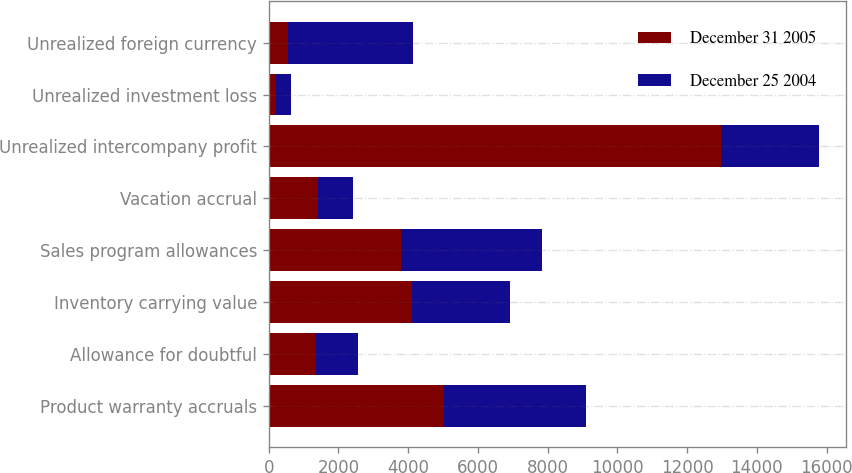Convert chart to OTSL. <chart><loc_0><loc_0><loc_500><loc_500><stacked_bar_chart><ecel><fcel>Product warranty accruals<fcel>Allowance for doubtful<fcel>Inventory carrying value<fcel>Sales program allowances<fcel>Vacation accrual<fcel>Unrealized intercompany profit<fcel>Unrealized investment loss<fcel>Unrealized foreign currency<nl><fcel>December 31 2005<fcel>5017<fcel>1361<fcel>4120<fcel>3798<fcel>1401<fcel>12978<fcel>219<fcel>550<nl><fcel>December 25 2004<fcel>4084<fcel>1187<fcel>2792<fcel>4035<fcel>1022<fcel>2792<fcel>433<fcel>3579<nl></chart> 